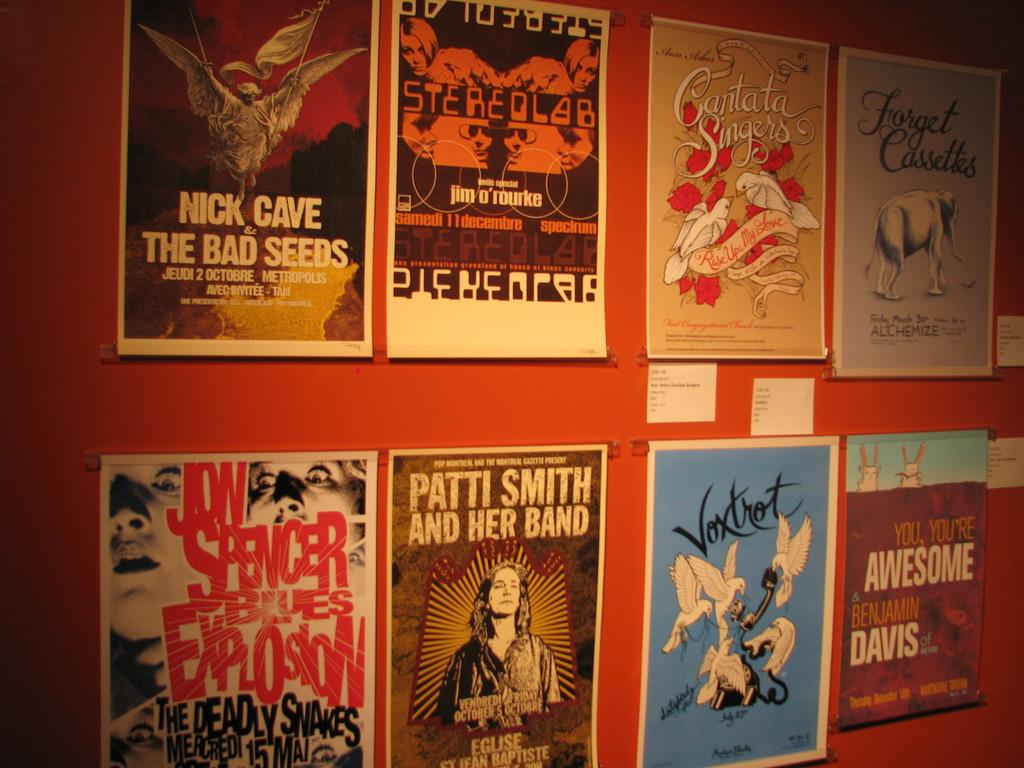<image>
Give a short and clear explanation of the subsequent image. a poster on the wall that says 'patti smith and her band' on it 